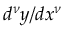<formula> <loc_0><loc_0><loc_500><loc_500>d ^ { \nu } y / d x ^ { \nu }</formula> 